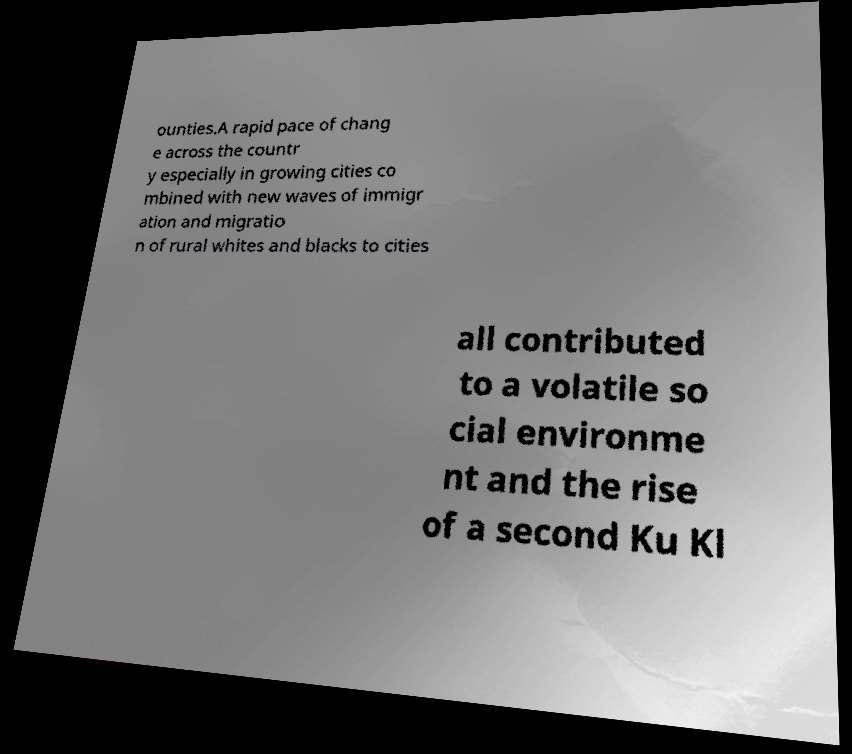Please identify and transcribe the text found in this image. ounties.A rapid pace of chang e across the countr y especially in growing cities co mbined with new waves of immigr ation and migratio n of rural whites and blacks to cities all contributed to a volatile so cial environme nt and the rise of a second Ku Kl 